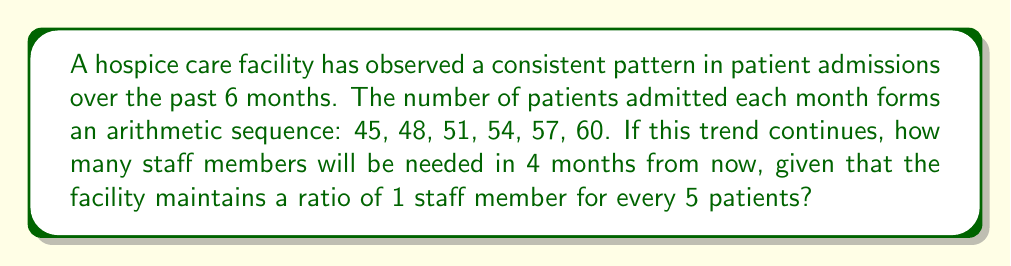Could you help me with this problem? Let's approach this step-by-step:

1) First, we need to identify the arithmetic sequence:
   $45, 48, 51, 54, 57, 60$

2) Find the common difference (d) of the sequence:
   $d = 48 - 45 = 51 - 48 = 54 - 51 = 3$

3) The sequence follows the formula:
   $a_n = a_1 + (n-1)d$
   Where $a_1 = 45$ (first term), $d = 3$, and $n$ is the term number

4) We need to find the 10th term (6 months observed + 4 months in the future):
   $a_{10} = 45 + (10-1)3 = 45 + 27 = 72$

5) So, in 4 months from now, there will be 72 patients

6) To find the number of staff needed, we use the ratio 1:5
   $\text{Number of staff} = \frac{\text{Number of patients}}{5} = \frac{72}{5} = 14.4$

7) Since we can't have a fractional staff member, we round up to the nearest whole number
Answer: 15 staff members 